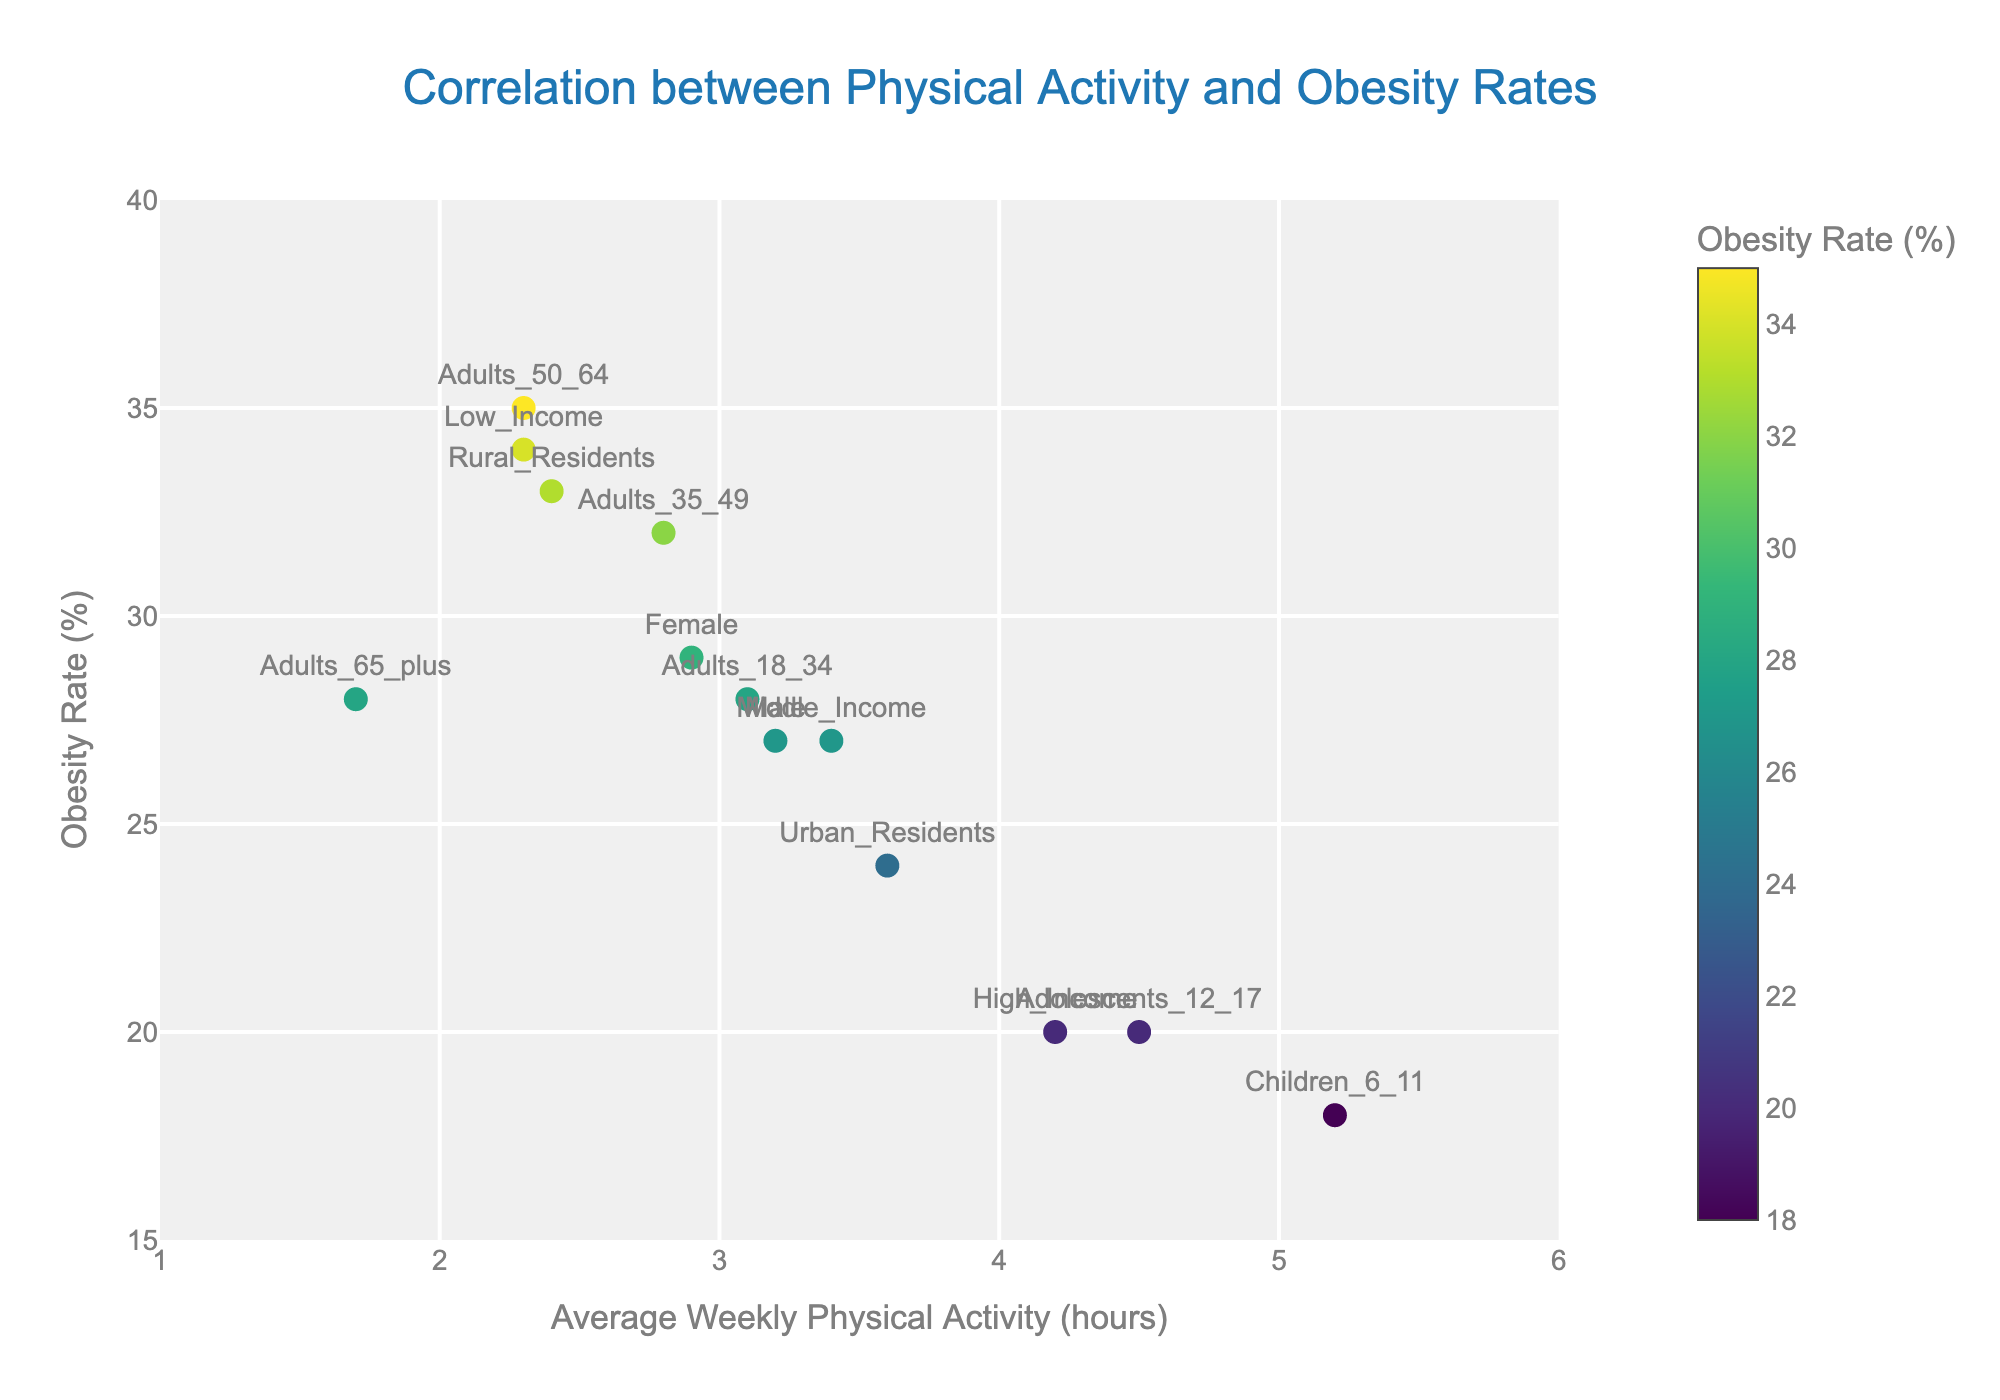What is the title of the scatter plot? The title is usually found at the top of the plot and describes the main focus. Here, it reads "Correlation between Physical Activity and Obesity Rates".
Answer: Correlation between Physical Activity and Obesity Rates What is the maximum obesity rate percentage shown on the plot? The y-axis indicates the obesity rate percentage, and the highest point on this axis is 35%.
Answer: 35% Which demographic group has the highest average weekly physical activity hours? The x-axis represents average weekly physical activity hours. By checking the position of the markers on the far right, we see that "Children_6_11" has the highest value at 5.2 hours.
Answer: Children_6_11 Which demographic group has the highest obesity rate percentage? By looking at the highest point of the y-axis, the marker that reaches the highest value on this axis represents the group with the highest obesity rate. "Adults_50_64" has an obesity rate of 35%.
Answer: Adults_50_64 What is the obesity rate for the "Urban_Residents" group, and how does it compare to "Rural_Residents"? "Urban_Residents" have an obesity rate of 24% and "Rural_Residents" have 33%. By comparing these values, we see that Urban Residents have a lower obesity rate by 9 percentage points.
Answer: Urban_Residents: 24%, Rural_Residents: 33% What are the average weekly physical activity hours for the "Low_Income" and "High_Income" groups? Look for the markers' positions on the x-axis for these groups. "Low_Income" is at 2.3 hours and "High_Income" is at 4.2 hours.
Answer: Low_Income: 2.3, High_Income: 4.2 Is there a trend observed between average weekly physical activity hours and obesity rates across the demographic groups? The scatter plot shows an inverse trend: generally, higher average weekly physical activity hours correspond to lower obesity rates.
Answer: Inverse trend Which gender has a higher obesity rate, male or female? By comparing the y-axis values where "Male" and "Female" markers are positioned, "Female" has a higher obesity rate at 29% versus "Male" at 27%.
Answer: Female Which group's marker is closest to the intersection of 2 hours of physical activity and 30% obesity rate? By locating the marker near the coordinates (2, 30) on the plot, the "Adults_50_64" marker is closest to this point.
Answer: Adults_50_64 What is the mean average weekly physical activity hours for adults (18+)? Add the physical activity hours for adults (3.1 + 2.8 + 2.3 + 1.7) and divide by the number of adult groups (4). The calculation is (3.1 + 2.8 + 2.3 + 1.7) / 4 = 2.475.
Answer: 2.475 hours 